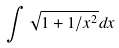Convert formula to latex. <formula><loc_0><loc_0><loc_500><loc_500>\int \sqrt { 1 + 1 / x ^ { 2 } } d x</formula> 